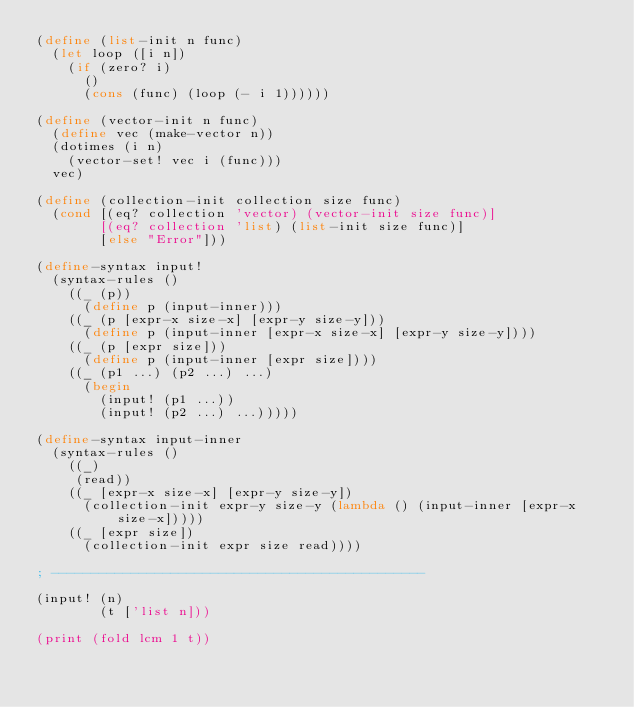Convert code to text. <code><loc_0><loc_0><loc_500><loc_500><_Scheme_>(define (list-init n func)
  (let loop ([i n])
    (if (zero? i)
      ()
      (cons (func) (loop (- i 1))))))

(define (vector-init n func)
  (define vec (make-vector n))
  (dotimes (i n)
    (vector-set! vec i (func)))
  vec)

(define (collection-init collection size func)
  (cond [(eq? collection 'vector) (vector-init size func)]
        [(eq? collection 'list) (list-init size func)]
        [else "Error"]))

(define-syntax input!
  (syntax-rules ()
    ((_ (p))
      (define p (input-inner)))
    ((_ (p [expr-x size-x] [expr-y size-y]))
      (define p (input-inner [expr-x size-x] [expr-y size-y])))
    ((_ (p [expr size]))
      (define p (input-inner [expr size])))
    ((_ (p1 ...) (p2 ...) ...)
      (begin 
        (input! (p1 ...))
        (input! (p2 ...) ...)))))

(define-syntax input-inner
  (syntax-rules ()
    ((_)
     (read))
    ((_ [expr-x size-x] [expr-y size-y])
      (collection-init expr-y size-y (lambda () (input-inner [expr-x size-x]))))
    ((_ [expr size])
      (collection-init expr size read))))

; -----------------------------------------------

(input! (n)
        (t ['list n]))

(print (fold lcm 1 t))</code> 